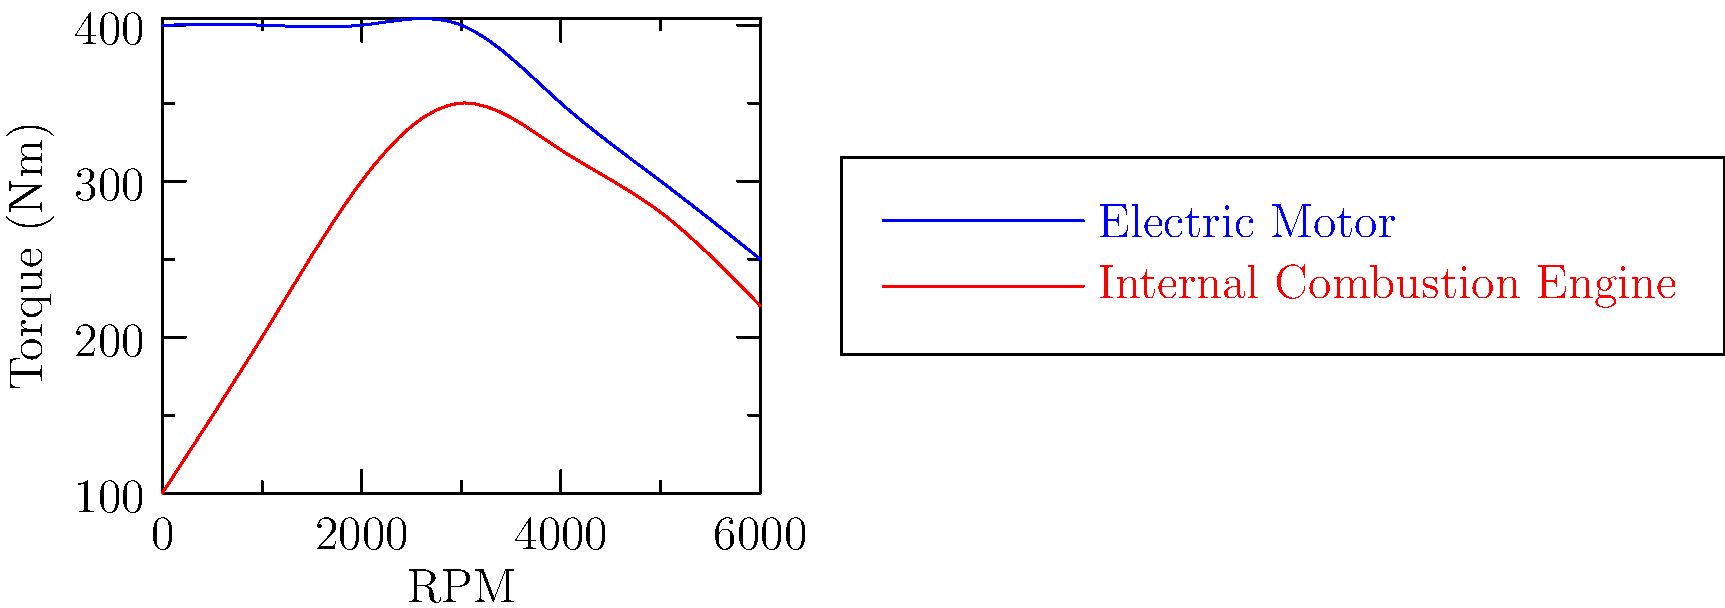Based on the line graph comparing torque output of electric motors and internal combustion engines, at which RPM range does the electric motor demonstrate a significant advantage in torque output? To answer this question, we need to analyze the graph and compare the torque output of both types of engines across different RPM ranges:

1. The blue line represents the electric motor's torque output.
2. The red line represents the internal combustion engine's torque output.

Let's examine the torque output at different RPM ranges:

1. 0-1000 RPM: The electric motor starts at about 400 Nm, while the internal combustion engine starts at about 100 Nm.
2. 1000-2000 RPM: The electric motor maintains 400 Nm, while the internal combustion engine increases to about 300 Nm.
3. 2000-3000 RPM: The electric motor still maintains 400 Nm, while the internal combustion engine reaches its peak at about 350 Nm.
4. 3000-6000 RPM: Both engines show a gradual decline in torque output.

The most significant advantage for the electric motor is observed in the lower RPM range, particularly from 0-2000 RPM. In this range, the electric motor provides a constant high torque of 400 Nm, while the internal combustion engine's torque is significantly lower and gradually increasing.

This characteristic makes electric motors particularly advantageous for quick acceleration from a standstill and low-speed driving scenarios, which are common in urban environments.
Answer: 0-2000 RPM 